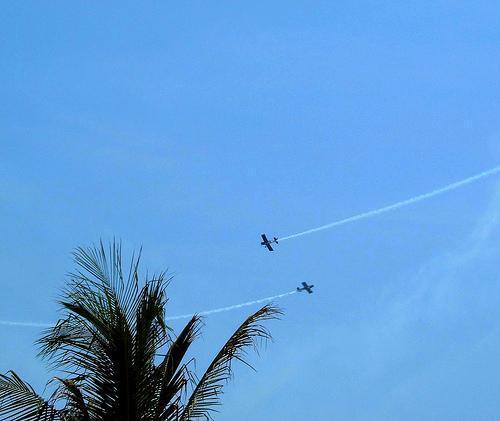How many planes are there?
Give a very brief answer. 2. 